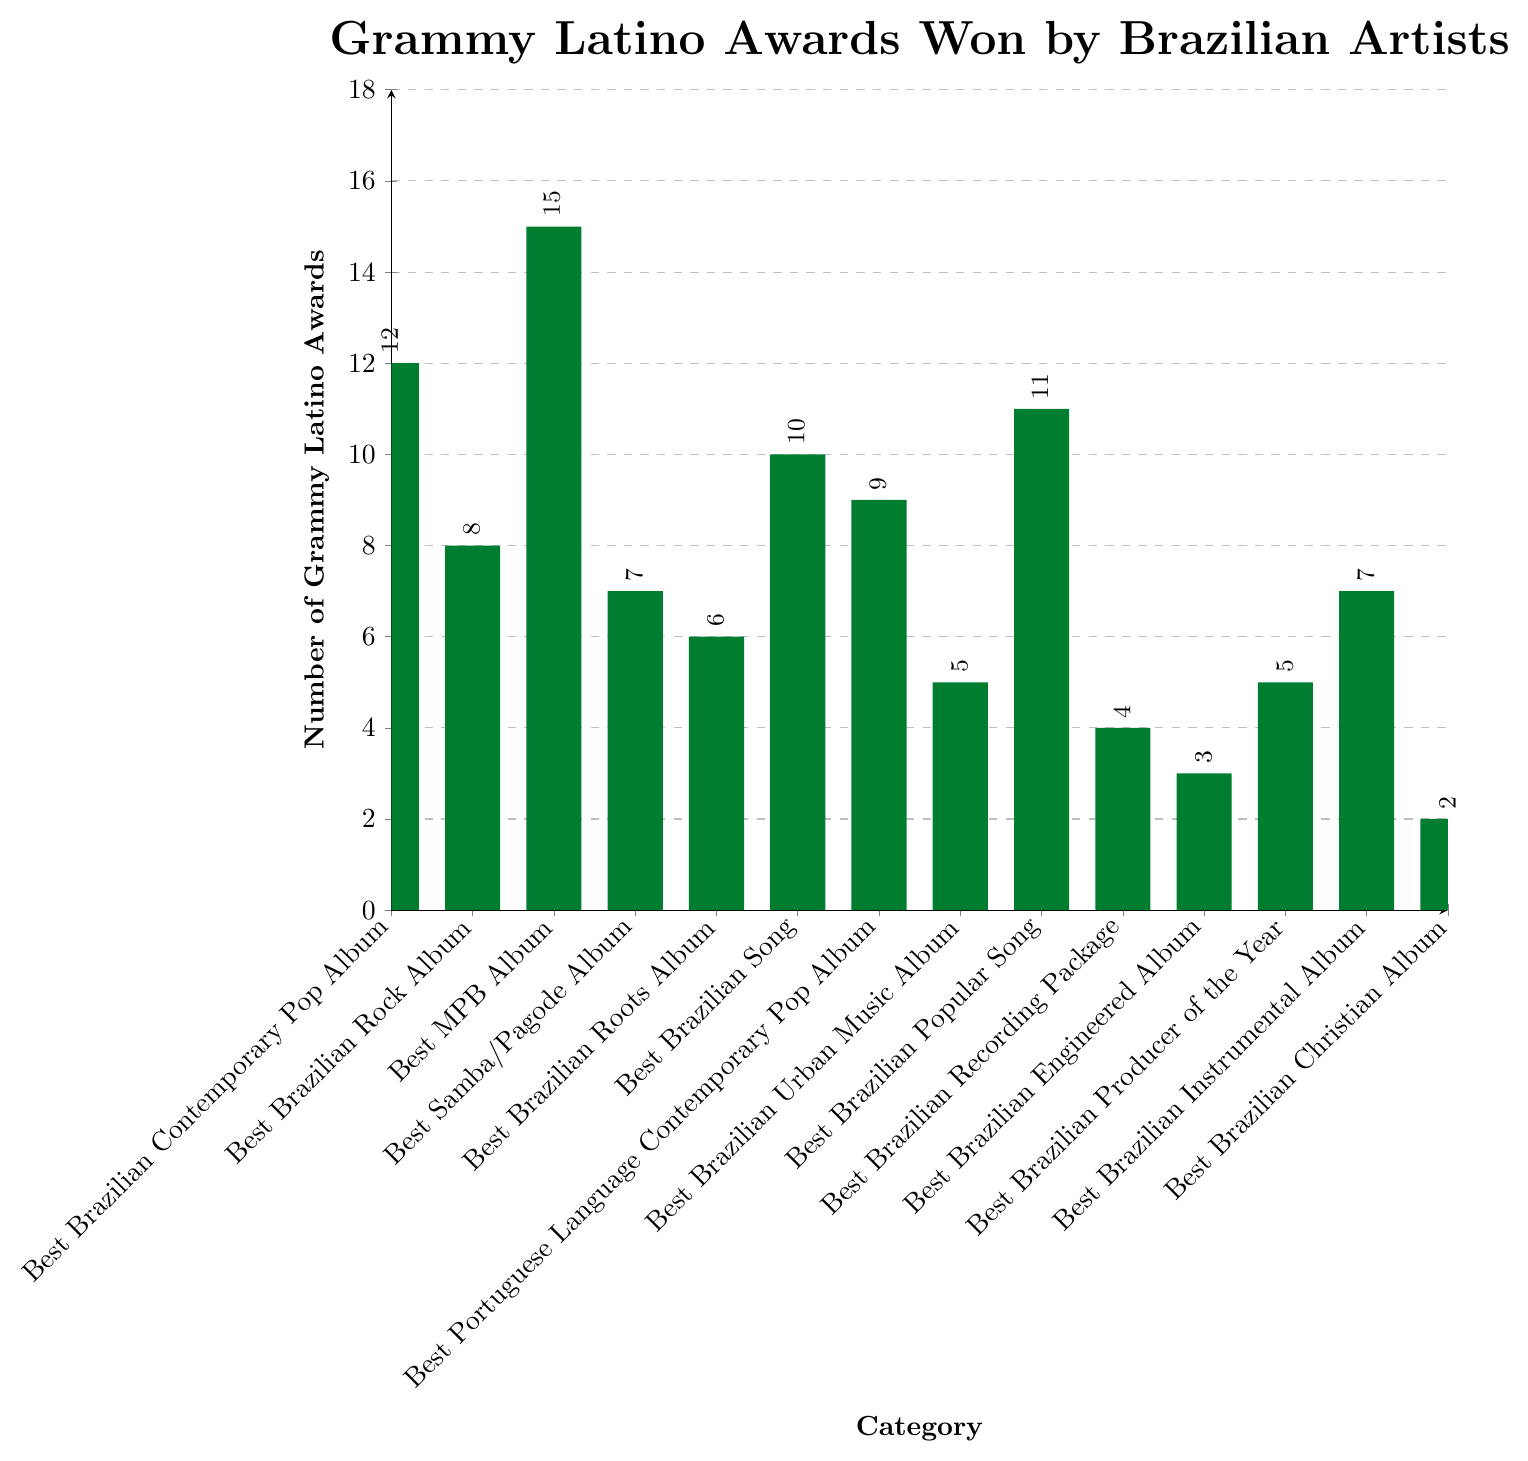Which category has the highest number of Grammy Latino Awards won by Brazilian artists? To determine the category with the highest number of awards, look for the tallest bar in the chart. The bar for the "Best MPB Album" category is the tallest.
Answer: Best MPB Album Which categories have won fewer than 5 Grammy Latino Awards? To identify categories with fewer than 5 awards, check the height of each bar. Categories "Best Brazilian Recording Package" and "Best Brazilian Engineered Album" have 4 and 3 awards respectively, while "Best Brazilian Christian Album" has 2, making 3 categories in total.
Answer: Best Brazilian Recording Package, Best Brazilian Engineered Album, Best Brazilian Christian Album What's the total number of Grammy Latino Awards won in "Best Brazilian Contemporary Pop Album" and "Best Brazilian Rock Album" combined? Add the number of awards in the two categories: 12 (Best Brazilian Contemporary Pop Album) + 8 (Best Brazilian Rock Album) = 20.
Answer: 20 How many more awards does the "Best MPB Album" category have compared to the "Best Brazilian Rock Album" category? Subtract the number of awards in the "Best Brazilian Rock Album" from the "Best MPB Album": 15 - 8 = 7.
Answer: 7 What's the average number of awards won across all the categories shown? Sum all the awards and divide by the number of categories: (12+8+15+7+6+10+9+5+11+4+3+5+7+2) / 14 = 104 / 14 ≈ 7.43.
Answer: 7.43 Which category has exactly half the number of awards as the "Best MPB Album"? Identify the number of awards in "Best MPB Album" which is 15, and find half of it (15 / 2 = 7.5) then look for the closest whole number. "Best Samba/Pagode Album" and "Best Brazilian Instrumental Album" have 7 awards each, which is the closest to half of 15.
Answer: Best Samba/Pagode Album, Best Brazilian Instrumental Album How much higher is the number of awards for "Best MPB Album" compared to "Best Brazilian Christian Album"? Subtract the award number for "Best Brazilian Christian Album" from "Best MPB Album": 15 - 2 = 13.
Answer: 13 How many categories have won more than 10 Grammy Latino Awards? Count the number of bars with a height over 10. Only "Best MPB Album" (15), "Best Brazilian Contemporary Pop Album" (12), and "Best Brazilian Popular Song" (11) have more than 10 awards, totaling 3 categories.
Answer: 3 What's the median number of Grammy Latino Awards won across the categories? To find the median, list the number of awards in ascending order: [2, 3, 4, 5, 5, 6, 7, 7, 8, 9, 10, 11, 12, 15]. The middle values are the 7th and 8th entries, which are both 7, so the median is 7.
Answer: 7 What's the difference in the total number of awards between the top 5 categories and the bottom 5 categories? The top 5 categories by the number of awards are: 15, 12, 11, 10, and 9. Their total is 57. The bottom 5 categories are: 2, 3, 4, 5, and 5. Their total is 19. The difference is 57 - 19 = 38.
Answer: 38 